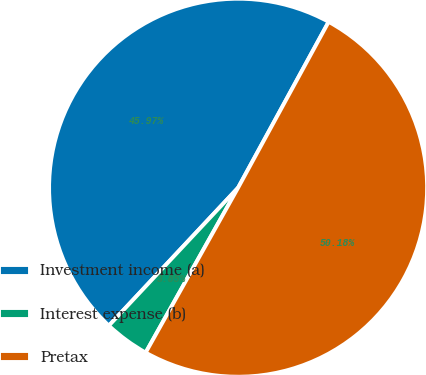Convert chart. <chart><loc_0><loc_0><loc_500><loc_500><pie_chart><fcel>Investment income (a)<fcel>Interest expense (b)<fcel>Pretax<nl><fcel>45.97%<fcel>3.85%<fcel>50.18%<nl></chart> 